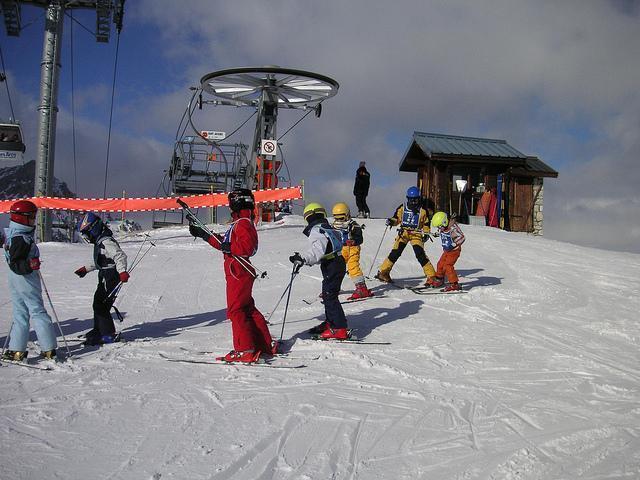How many people are in the picture?
Give a very brief answer. 8. How many people are there?
Give a very brief answer. 5. How many dogs has red plate?
Give a very brief answer. 0. 